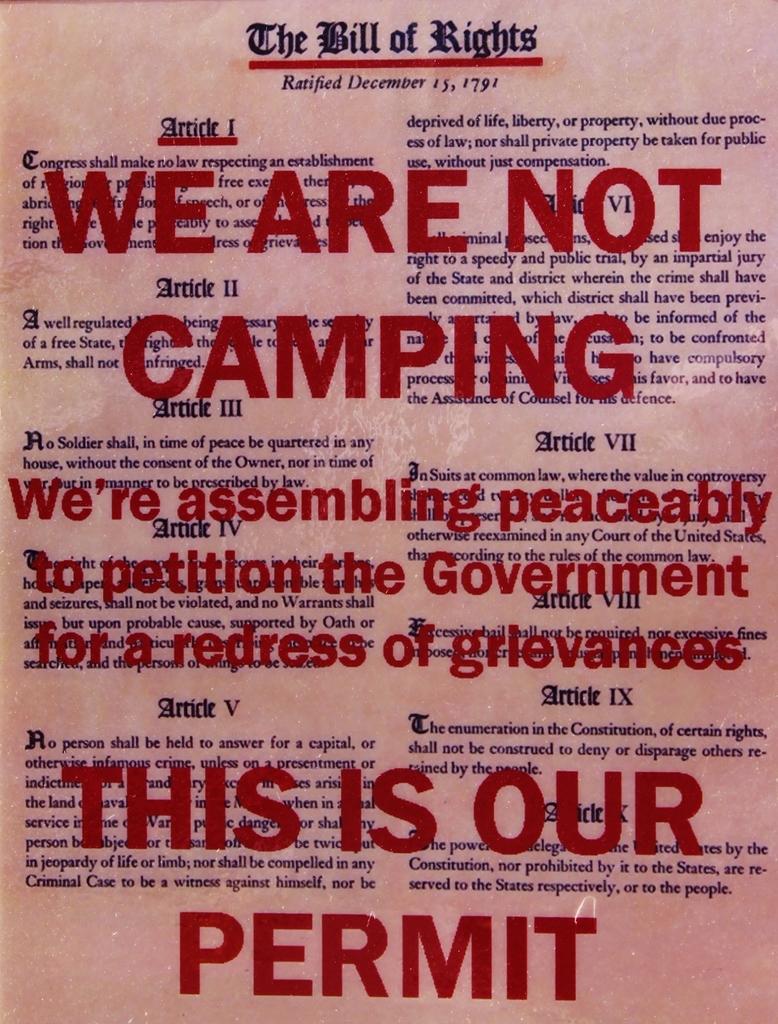What is the title of this document?
Make the answer very short. The bill of rights. When was the bill of rights ratified?
Give a very brief answer. December 15, 1791. 